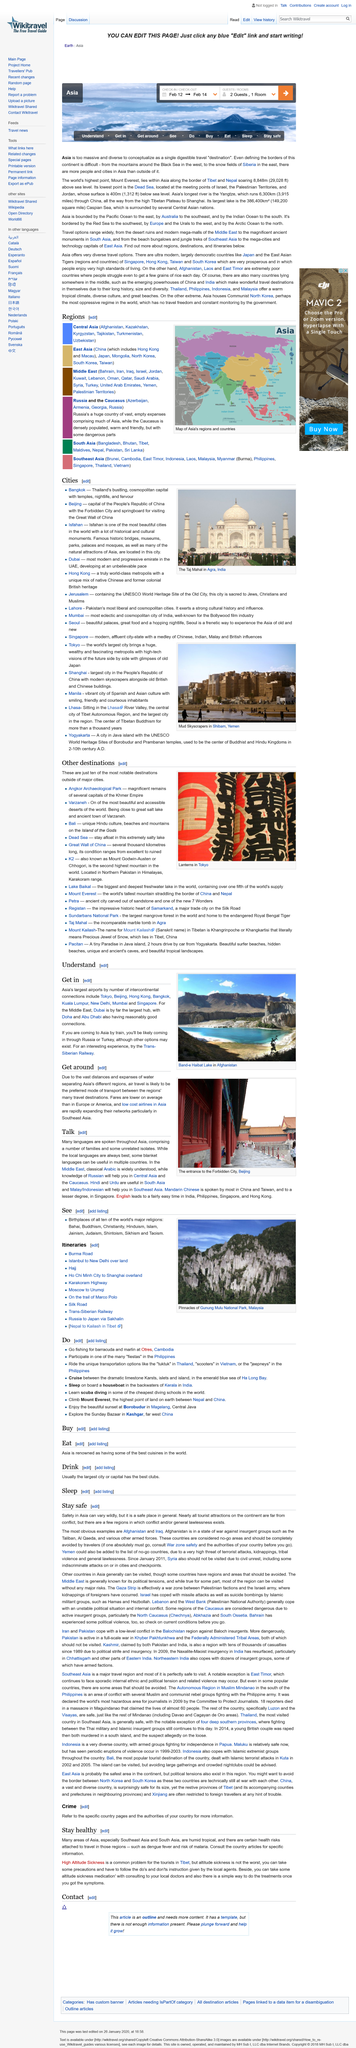Highlight a few significant elements in this photo. It is imperative that if you must enter or operate within high-risk areas, you should consult with War Zone Safety and seek guidance from the relevant authorities of your country before doing so. The climate in Southeast and South Asia is characterized by high humidity and a tropical climate. There are certain health risks, such as dengue fever and the risk of malaria, when traveling in South and Southeast Asia. High altitude sickness is a prevalent issue for tourists traveling to Tibet, yet it is treatable with medication under the guidance of a medical professional. According to the article "Stay safe," it is generally safe to travel to Asia, as nearly all tourist attractions on the continent are far from any conflicts. 